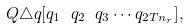Convert formula to latex. <formula><loc_0><loc_0><loc_500><loc_500>Q \triangle q [ q _ { 1 } \ q _ { 2 } \ q _ { 3 } \cdots q _ { 2 T n _ { r } } ] ,</formula> 